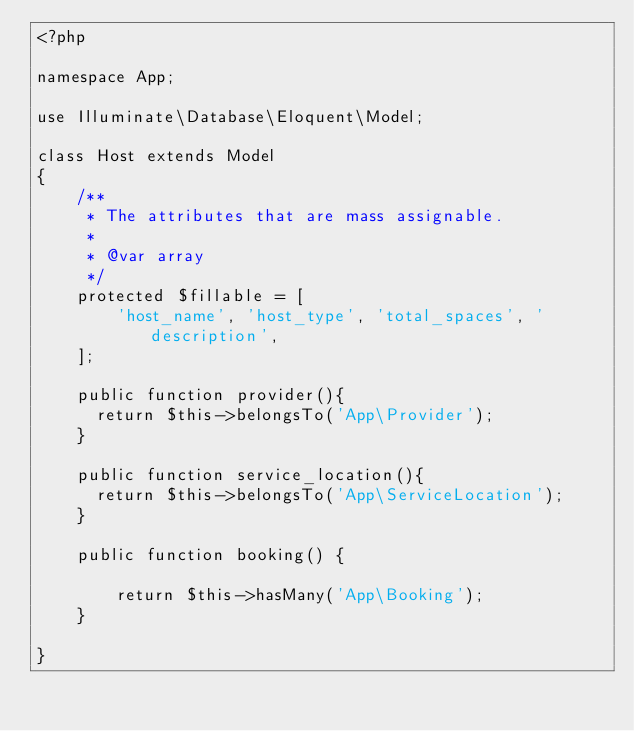<code> <loc_0><loc_0><loc_500><loc_500><_PHP_><?php

namespace App;

use Illuminate\Database\Eloquent\Model;

class Host extends Model
{
    /**
     * The attributes that are mass assignable.
     *
     * @var array
     */
    protected $fillable = [
        'host_name', 'host_type', 'total_spaces', 'description',
    ];

    public function provider(){
    	return $this->belongsTo('App\Provider');
    } 

    public function service_location(){
    	return $this->belongsTo('App\ServiceLocation');
    } 

    public function booking() {

        return $this->hasMany('App\Booking');
    }

}
</code> 